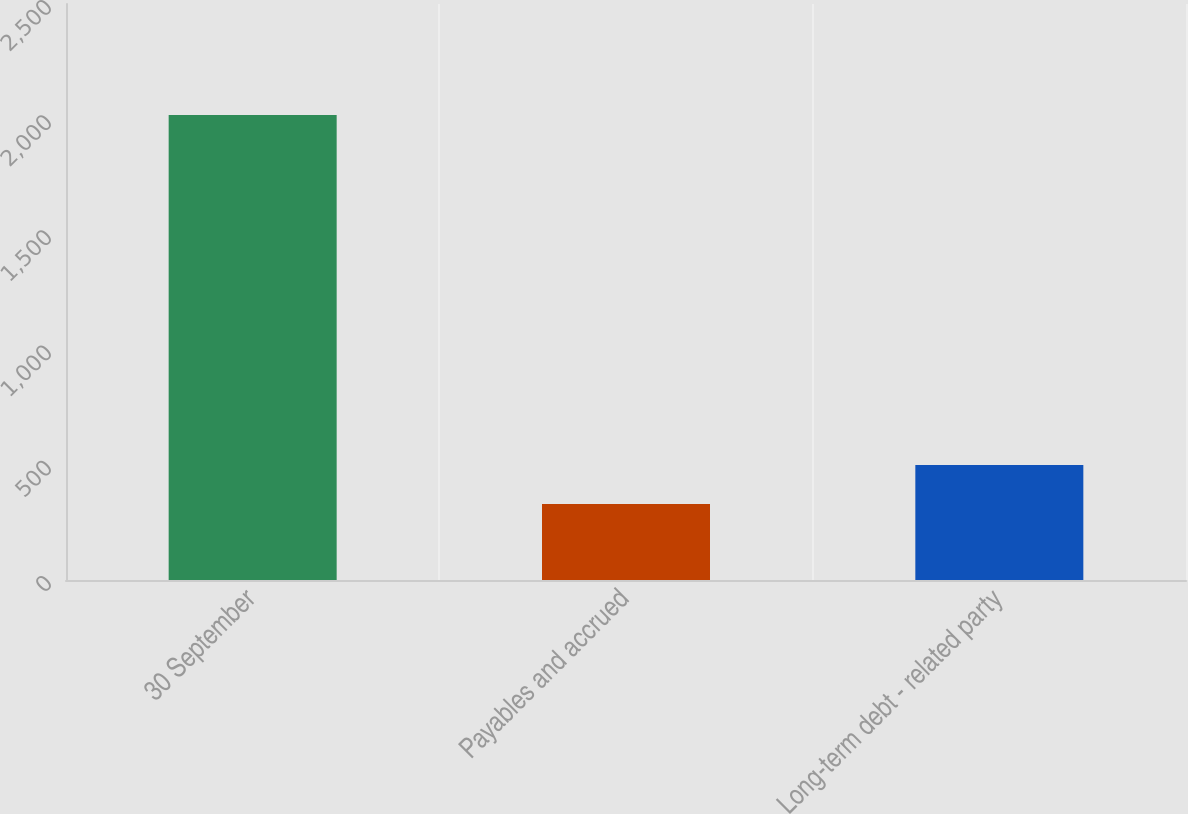<chart> <loc_0><loc_0><loc_500><loc_500><bar_chart><fcel>30 September<fcel>Payables and accrued<fcel>Long-term debt - related party<nl><fcel>2018<fcel>330<fcel>498.8<nl></chart> 